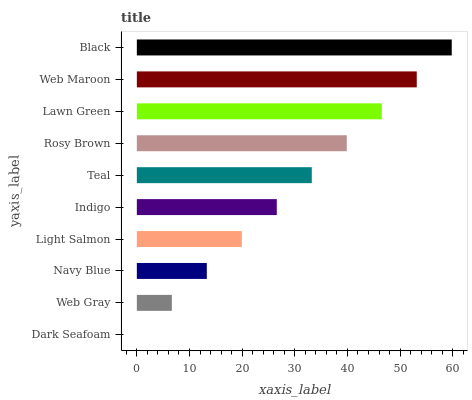Is Dark Seafoam the minimum?
Answer yes or no. Yes. Is Black the maximum?
Answer yes or no. Yes. Is Web Gray the minimum?
Answer yes or no. No. Is Web Gray the maximum?
Answer yes or no. No. Is Web Gray greater than Dark Seafoam?
Answer yes or no. Yes. Is Dark Seafoam less than Web Gray?
Answer yes or no. Yes. Is Dark Seafoam greater than Web Gray?
Answer yes or no. No. Is Web Gray less than Dark Seafoam?
Answer yes or no. No. Is Teal the high median?
Answer yes or no. Yes. Is Indigo the low median?
Answer yes or no. Yes. Is Rosy Brown the high median?
Answer yes or no. No. Is Web Maroon the low median?
Answer yes or no. No. 